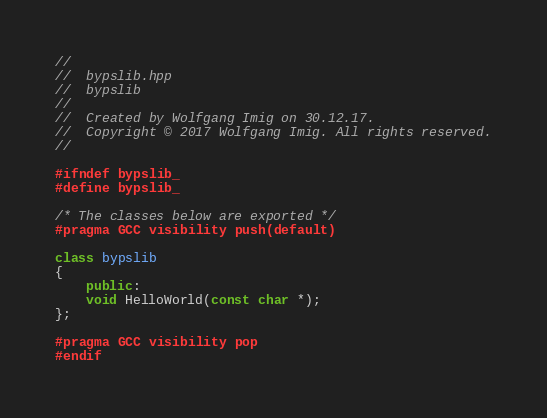<code> <loc_0><loc_0><loc_500><loc_500><_C++_>//
//  bypslib.hpp
//  bypslib
//
//  Created by Wolfgang Imig on 30.12.17.
//  Copyright © 2017 Wolfgang Imig. All rights reserved.
//

#ifndef bypslib_
#define bypslib_

/* The classes below are exported */
#pragma GCC visibility push(default)

class bypslib
{
    public:
    void HelloWorld(const char *);
};

#pragma GCC visibility pop
#endif
</code> 